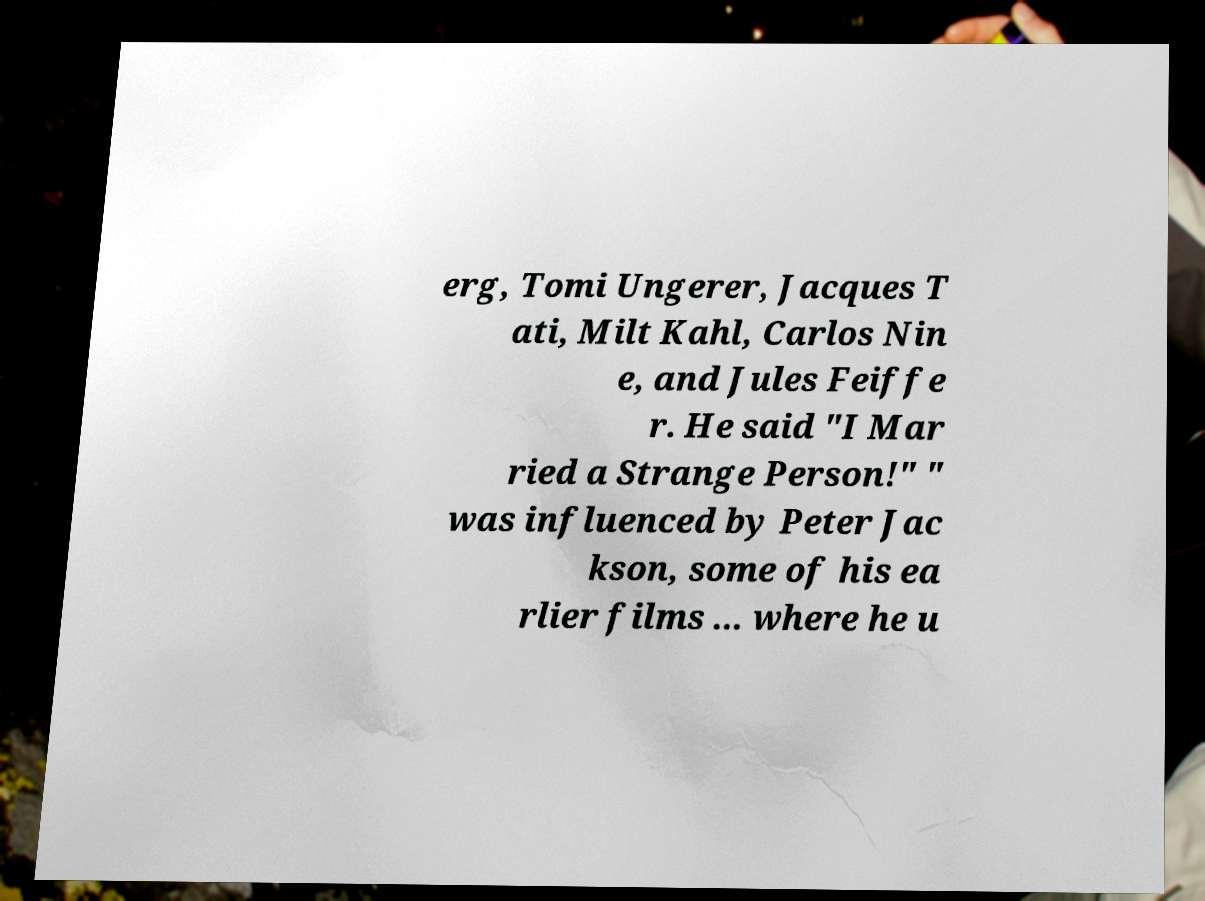Could you extract and type out the text from this image? erg, Tomi Ungerer, Jacques T ati, Milt Kahl, Carlos Nin e, and Jules Feiffe r. He said "I Mar ried a Strange Person!" " was influenced by Peter Jac kson, some of his ea rlier films ... where he u 